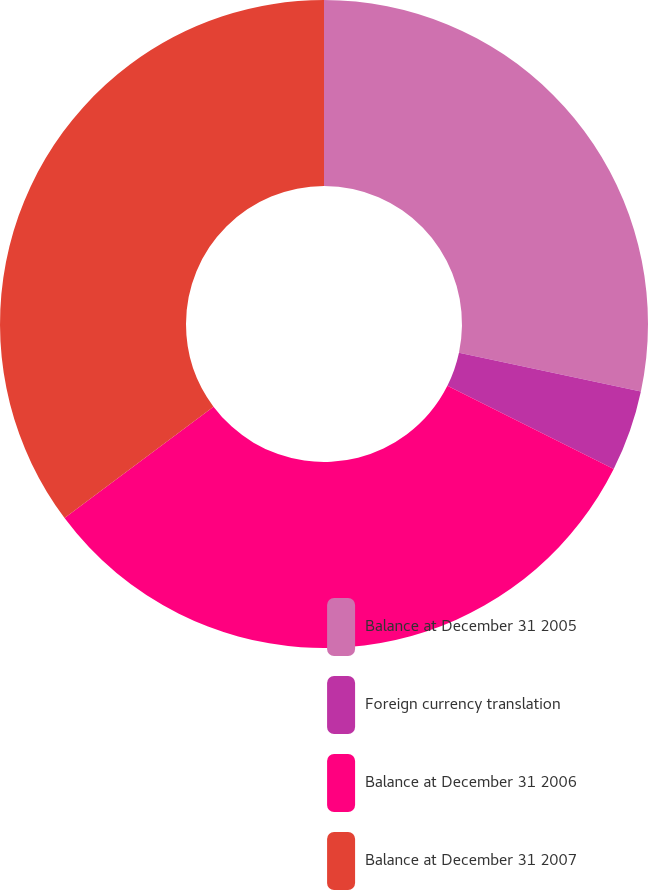<chart> <loc_0><loc_0><loc_500><loc_500><pie_chart><fcel>Balance at December 31 2005<fcel>Foreign currency translation<fcel>Balance at December 31 2006<fcel>Balance at December 31 2007<nl><fcel>28.34%<fcel>4.05%<fcel>32.39%<fcel>35.22%<nl></chart> 